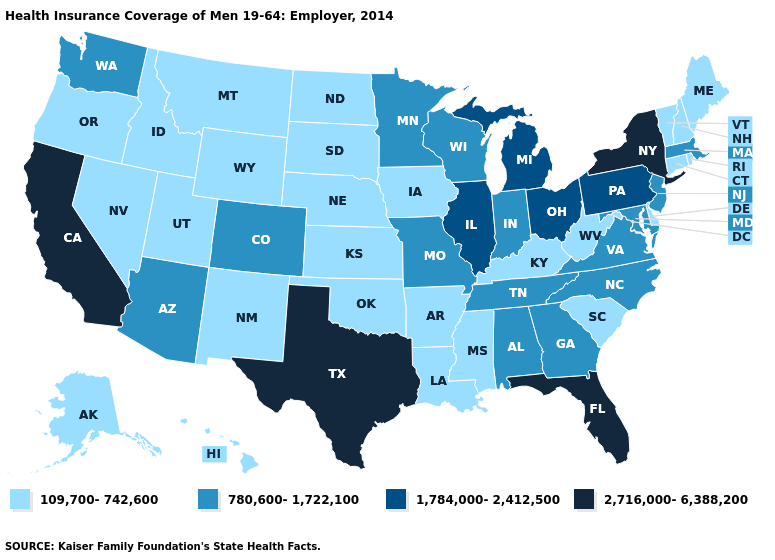Which states hav the highest value in the South?
Short answer required. Florida, Texas. What is the value of Rhode Island?
Be succinct. 109,700-742,600. How many symbols are there in the legend?
Give a very brief answer. 4. What is the value of Michigan?
Keep it brief. 1,784,000-2,412,500. Name the states that have a value in the range 109,700-742,600?
Write a very short answer. Alaska, Arkansas, Connecticut, Delaware, Hawaii, Idaho, Iowa, Kansas, Kentucky, Louisiana, Maine, Mississippi, Montana, Nebraska, Nevada, New Hampshire, New Mexico, North Dakota, Oklahoma, Oregon, Rhode Island, South Carolina, South Dakota, Utah, Vermont, West Virginia, Wyoming. What is the value of Kansas?
Quick response, please. 109,700-742,600. Name the states that have a value in the range 780,600-1,722,100?
Concise answer only. Alabama, Arizona, Colorado, Georgia, Indiana, Maryland, Massachusetts, Minnesota, Missouri, New Jersey, North Carolina, Tennessee, Virginia, Washington, Wisconsin. What is the value of Ohio?
Answer briefly. 1,784,000-2,412,500. Is the legend a continuous bar?
Be succinct. No. Name the states that have a value in the range 109,700-742,600?
Short answer required. Alaska, Arkansas, Connecticut, Delaware, Hawaii, Idaho, Iowa, Kansas, Kentucky, Louisiana, Maine, Mississippi, Montana, Nebraska, Nevada, New Hampshire, New Mexico, North Dakota, Oklahoma, Oregon, Rhode Island, South Carolina, South Dakota, Utah, Vermont, West Virginia, Wyoming. What is the value of North Dakota?
Short answer required. 109,700-742,600. Does the first symbol in the legend represent the smallest category?
Quick response, please. Yes. What is the value of Colorado?
Give a very brief answer. 780,600-1,722,100. Name the states that have a value in the range 780,600-1,722,100?
Keep it brief. Alabama, Arizona, Colorado, Georgia, Indiana, Maryland, Massachusetts, Minnesota, Missouri, New Jersey, North Carolina, Tennessee, Virginia, Washington, Wisconsin. Does Washington have the lowest value in the West?
Quick response, please. No. 